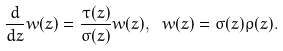<formula> <loc_0><loc_0><loc_500><loc_500>\frac { d } { d z } w ( z ) = \frac { \tau ( z ) } { \sigma ( z ) } w ( z ) , \text { } w ( z ) = \sigma ( z ) \rho ( z ) .</formula> 